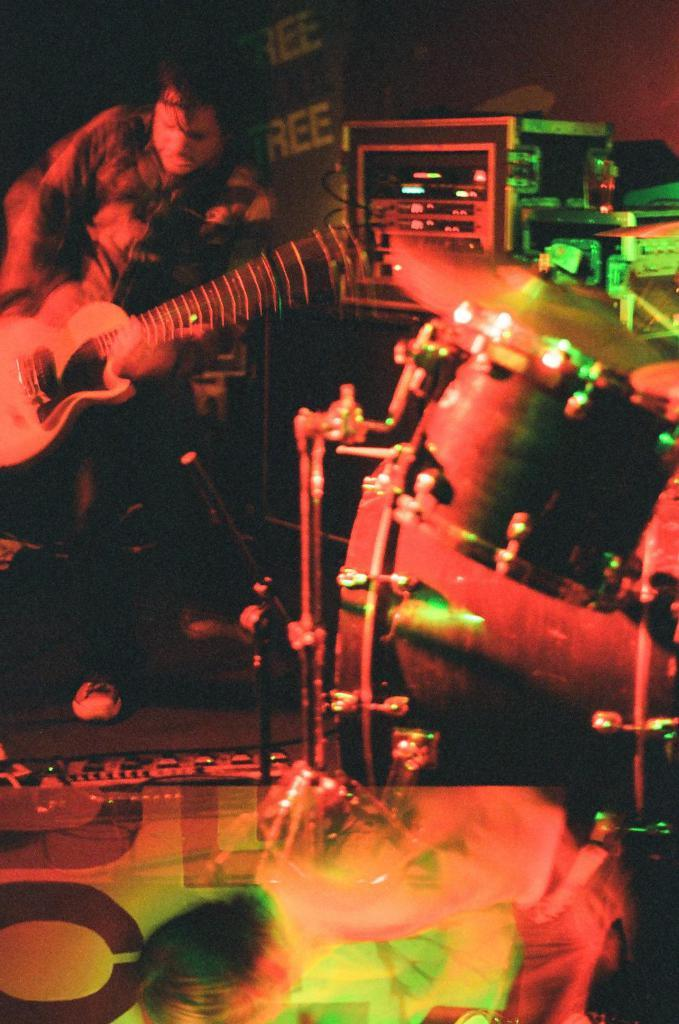What is the man in the image holding? The man is holding a guitar. What else can be seen in the image besides the man and the guitar? There is a glass, a drum device, and other musical instruments in the image. What is in the background of the image? There is a poster in the background of the image. Can you see any fangs on the man in the image? There are no fangs visible on the man in the image. What type of bird is sitting on the drum device in the image? There are no birds present in the image; it only features musical instruments and a man holding a guitar. 